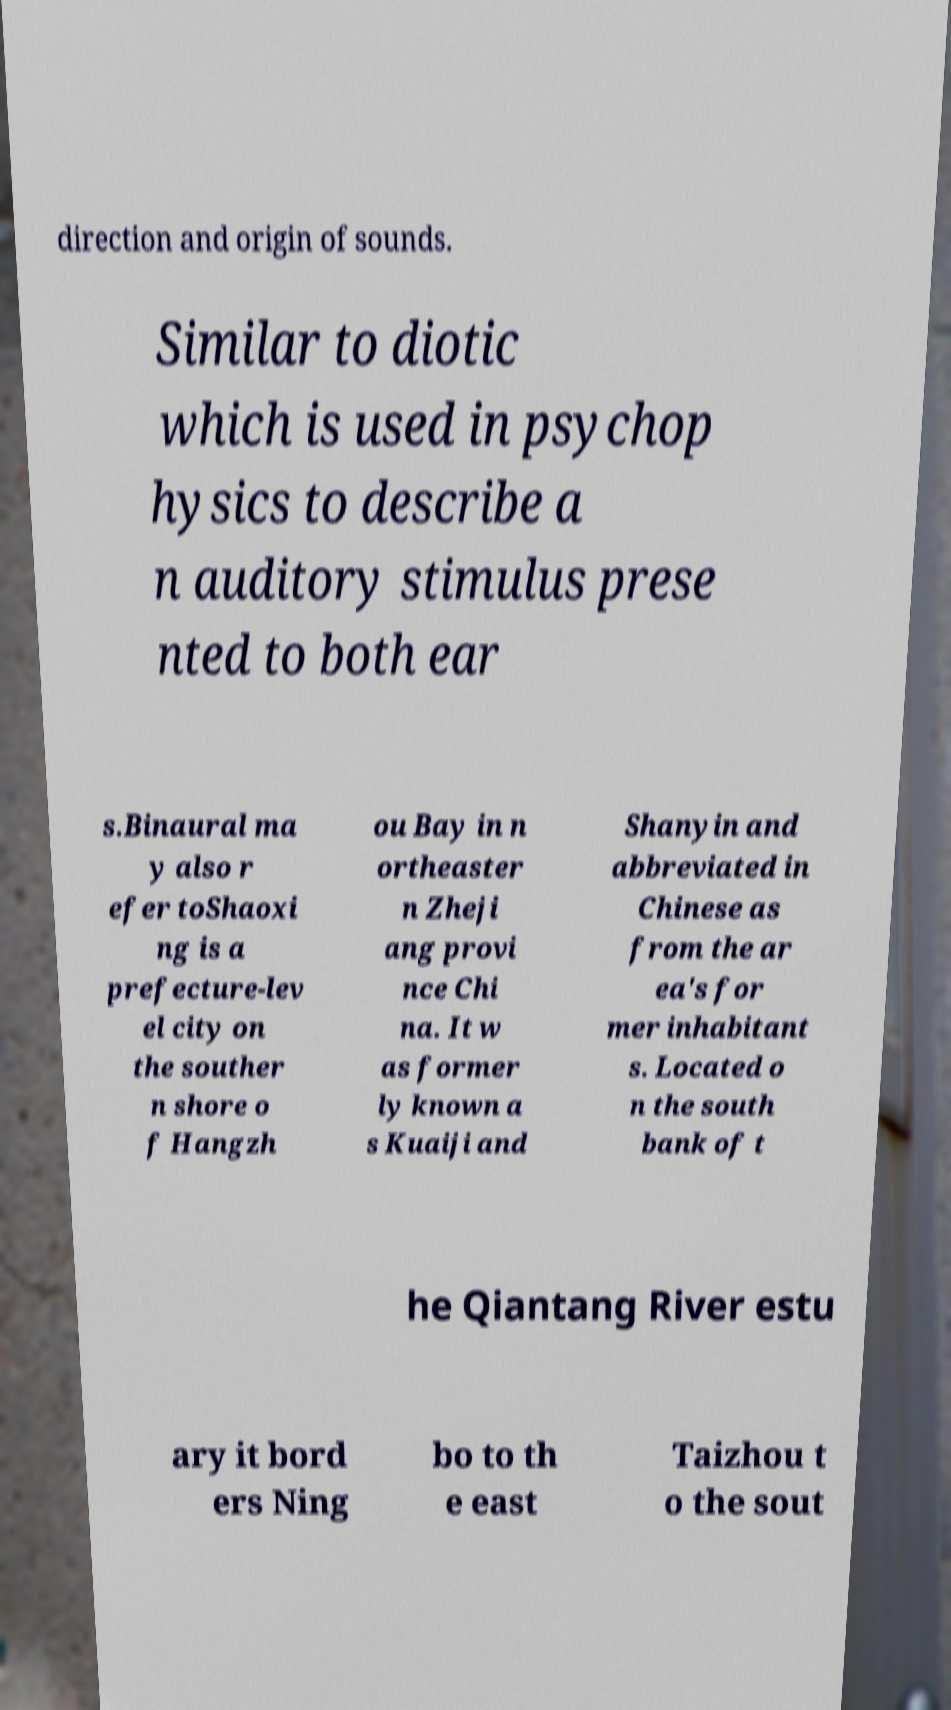Please read and relay the text visible in this image. What does it say? direction and origin of sounds. Similar to diotic which is used in psychop hysics to describe a n auditory stimulus prese nted to both ear s.Binaural ma y also r efer toShaoxi ng is a prefecture-lev el city on the souther n shore o f Hangzh ou Bay in n ortheaster n Zheji ang provi nce Chi na. It w as former ly known a s Kuaiji and Shanyin and abbreviated in Chinese as from the ar ea's for mer inhabitant s. Located o n the south bank of t he Qiantang River estu ary it bord ers Ning bo to th e east Taizhou t o the sout 